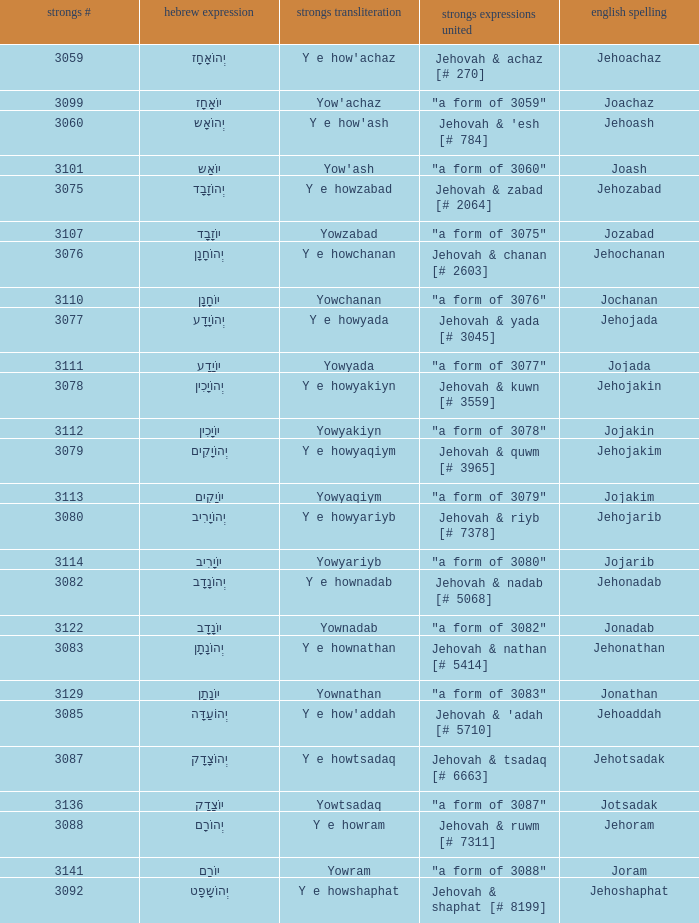What is the english spelling of the word that has the strongs trasliteration of y e howram? Jehoram. 